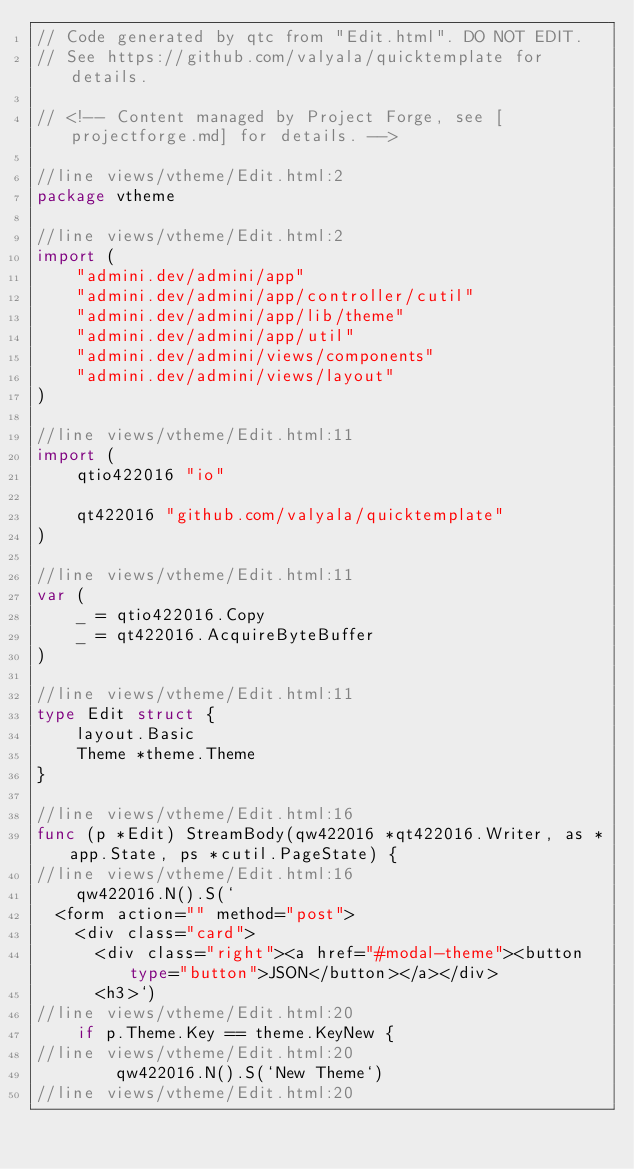Convert code to text. <code><loc_0><loc_0><loc_500><loc_500><_Go_>// Code generated by qtc from "Edit.html". DO NOT EDIT.
// See https://github.com/valyala/quicktemplate for details.

// <!-- Content managed by Project Forge, see [projectforge.md] for details. -->

//line views/vtheme/Edit.html:2
package vtheme

//line views/vtheme/Edit.html:2
import (
	"admini.dev/admini/app"
	"admini.dev/admini/app/controller/cutil"
	"admini.dev/admini/app/lib/theme"
	"admini.dev/admini/app/util"
	"admini.dev/admini/views/components"
	"admini.dev/admini/views/layout"
)

//line views/vtheme/Edit.html:11
import (
	qtio422016 "io"

	qt422016 "github.com/valyala/quicktemplate"
)

//line views/vtheme/Edit.html:11
var (
	_ = qtio422016.Copy
	_ = qt422016.AcquireByteBuffer
)

//line views/vtheme/Edit.html:11
type Edit struct {
	layout.Basic
	Theme *theme.Theme
}

//line views/vtheme/Edit.html:16
func (p *Edit) StreamBody(qw422016 *qt422016.Writer, as *app.State, ps *cutil.PageState) {
//line views/vtheme/Edit.html:16
	qw422016.N().S(`
  <form action="" method="post">
    <div class="card">
      <div class="right"><a href="#modal-theme"><button type="button">JSON</button></a></div>
      <h3>`)
//line views/vtheme/Edit.html:20
	if p.Theme.Key == theme.KeyNew {
//line views/vtheme/Edit.html:20
		qw422016.N().S(`New Theme`)
//line views/vtheme/Edit.html:20</code> 